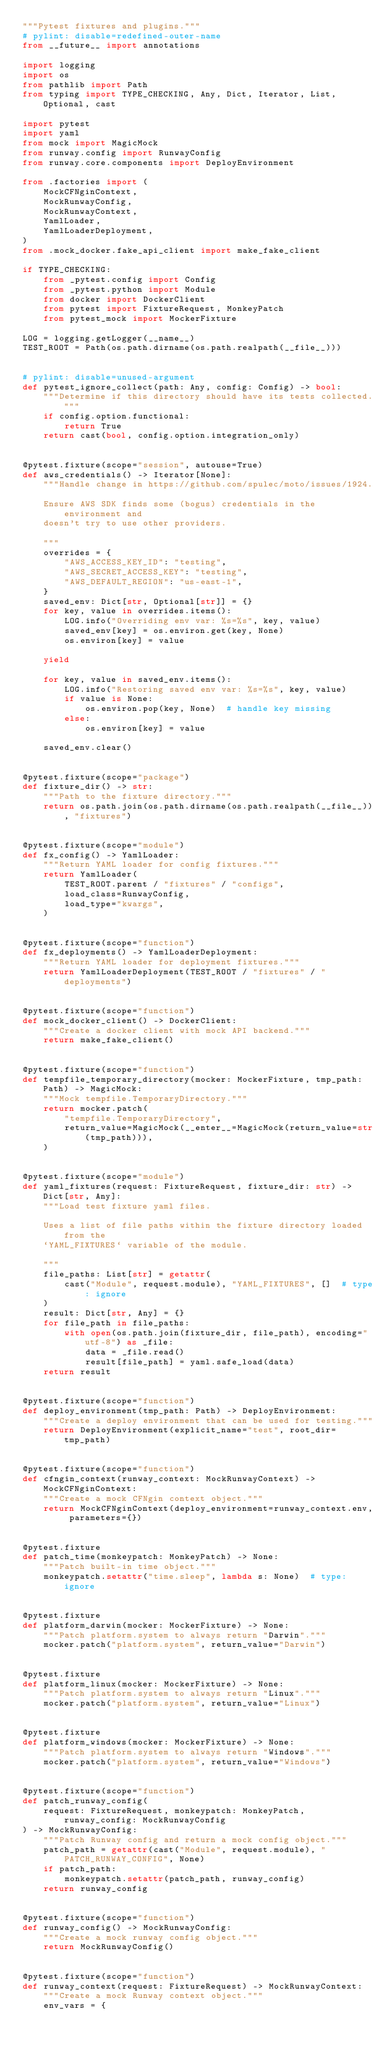<code> <loc_0><loc_0><loc_500><loc_500><_Python_>"""Pytest fixtures and plugins."""
# pylint: disable=redefined-outer-name
from __future__ import annotations

import logging
import os
from pathlib import Path
from typing import TYPE_CHECKING, Any, Dict, Iterator, List, Optional, cast

import pytest
import yaml
from mock import MagicMock
from runway.config import RunwayConfig
from runway.core.components import DeployEnvironment

from .factories import (
    MockCFNginContext,
    MockRunwayConfig,
    MockRunwayContext,
    YamlLoader,
    YamlLoaderDeployment,
)
from .mock_docker.fake_api_client import make_fake_client

if TYPE_CHECKING:
    from _pytest.config import Config
    from _pytest.python import Module
    from docker import DockerClient
    from pytest import FixtureRequest, MonkeyPatch
    from pytest_mock import MockerFixture

LOG = logging.getLogger(__name__)
TEST_ROOT = Path(os.path.dirname(os.path.realpath(__file__)))


# pylint: disable=unused-argument
def pytest_ignore_collect(path: Any, config: Config) -> bool:
    """Determine if this directory should have its tests collected."""
    if config.option.functional:
        return True
    return cast(bool, config.option.integration_only)


@pytest.fixture(scope="session", autouse=True)
def aws_credentials() -> Iterator[None]:
    """Handle change in https://github.com/spulec/moto/issues/1924.

    Ensure AWS SDK finds some (bogus) credentials in the environment and
    doesn't try to use other providers.

    """
    overrides = {
        "AWS_ACCESS_KEY_ID": "testing",
        "AWS_SECRET_ACCESS_KEY": "testing",
        "AWS_DEFAULT_REGION": "us-east-1",
    }
    saved_env: Dict[str, Optional[str]] = {}
    for key, value in overrides.items():
        LOG.info("Overriding env var: %s=%s", key, value)
        saved_env[key] = os.environ.get(key, None)
        os.environ[key] = value

    yield

    for key, value in saved_env.items():
        LOG.info("Restoring saved env var: %s=%s", key, value)
        if value is None:
            os.environ.pop(key, None)  # handle key missing
        else:
            os.environ[key] = value

    saved_env.clear()


@pytest.fixture(scope="package")
def fixture_dir() -> str:
    """Path to the fixture directory."""
    return os.path.join(os.path.dirname(os.path.realpath(__file__)), "fixtures")


@pytest.fixture(scope="module")
def fx_config() -> YamlLoader:
    """Return YAML loader for config fixtures."""
    return YamlLoader(
        TEST_ROOT.parent / "fixtures" / "configs",
        load_class=RunwayConfig,
        load_type="kwargs",
    )


@pytest.fixture(scope="function")
def fx_deployments() -> YamlLoaderDeployment:
    """Return YAML loader for deployment fixtures."""
    return YamlLoaderDeployment(TEST_ROOT / "fixtures" / "deployments")


@pytest.fixture(scope="function")
def mock_docker_client() -> DockerClient:
    """Create a docker client with mock API backend."""
    return make_fake_client()


@pytest.fixture(scope="function")
def tempfile_temporary_directory(mocker: MockerFixture, tmp_path: Path) -> MagicMock:
    """Mock tempfile.TemporaryDirectory."""
    return mocker.patch(
        "tempfile.TemporaryDirectory",
        return_value=MagicMock(__enter__=MagicMock(return_value=str(tmp_path))),
    )


@pytest.fixture(scope="module")
def yaml_fixtures(request: FixtureRequest, fixture_dir: str) -> Dict[str, Any]:
    """Load test fixture yaml files.

    Uses a list of file paths within the fixture directory loaded from the
    `YAML_FIXTURES` variable of the module.

    """
    file_paths: List[str] = getattr(
        cast("Module", request.module), "YAML_FIXTURES", []  # type: ignore
    )
    result: Dict[str, Any] = {}
    for file_path in file_paths:
        with open(os.path.join(fixture_dir, file_path), encoding="utf-8") as _file:
            data = _file.read()
            result[file_path] = yaml.safe_load(data)
    return result


@pytest.fixture(scope="function")
def deploy_environment(tmp_path: Path) -> DeployEnvironment:
    """Create a deploy environment that can be used for testing."""
    return DeployEnvironment(explicit_name="test", root_dir=tmp_path)


@pytest.fixture(scope="function")
def cfngin_context(runway_context: MockRunwayContext) -> MockCFNginContext:
    """Create a mock CFNgin context object."""
    return MockCFNginContext(deploy_environment=runway_context.env, parameters={})


@pytest.fixture
def patch_time(monkeypatch: MonkeyPatch) -> None:
    """Patch built-in time object."""
    monkeypatch.setattr("time.sleep", lambda s: None)  # type: ignore


@pytest.fixture
def platform_darwin(mocker: MockerFixture) -> None:
    """Patch platform.system to always return "Darwin"."""
    mocker.patch("platform.system", return_value="Darwin")


@pytest.fixture
def platform_linux(mocker: MockerFixture) -> None:
    """Patch platform.system to always return "Linux"."""
    mocker.patch("platform.system", return_value="Linux")


@pytest.fixture
def platform_windows(mocker: MockerFixture) -> None:
    """Patch platform.system to always return "Windows"."""
    mocker.patch("platform.system", return_value="Windows")


@pytest.fixture(scope="function")
def patch_runway_config(
    request: FixtureRequest, monkeypatch: MonkeyPatch, runway_config: MockRunwayConfig
) -> MockRunwayConfig:
    """Patch Runway config and return a mock config object."""
    patch_path = getattr(cast("Module", request.module), "PATCH_RUNWAY_CONFIG", None)
    if patch_path:
        monkeypatch.setattr(patch_path, runway_config)
    return runway_config


@pytest.fixture(scope="function")
def runway_config() -> MockRunwayConfig:
    """Create a mock runway config object."""
    return MockRunwayConfig()


@pytest.fixture(scope="function")
def runway_context(request: FixtureRequest) -> MockRunwayContext:
    """Create a mock Runway context object."""
    env_vars = {</code> 